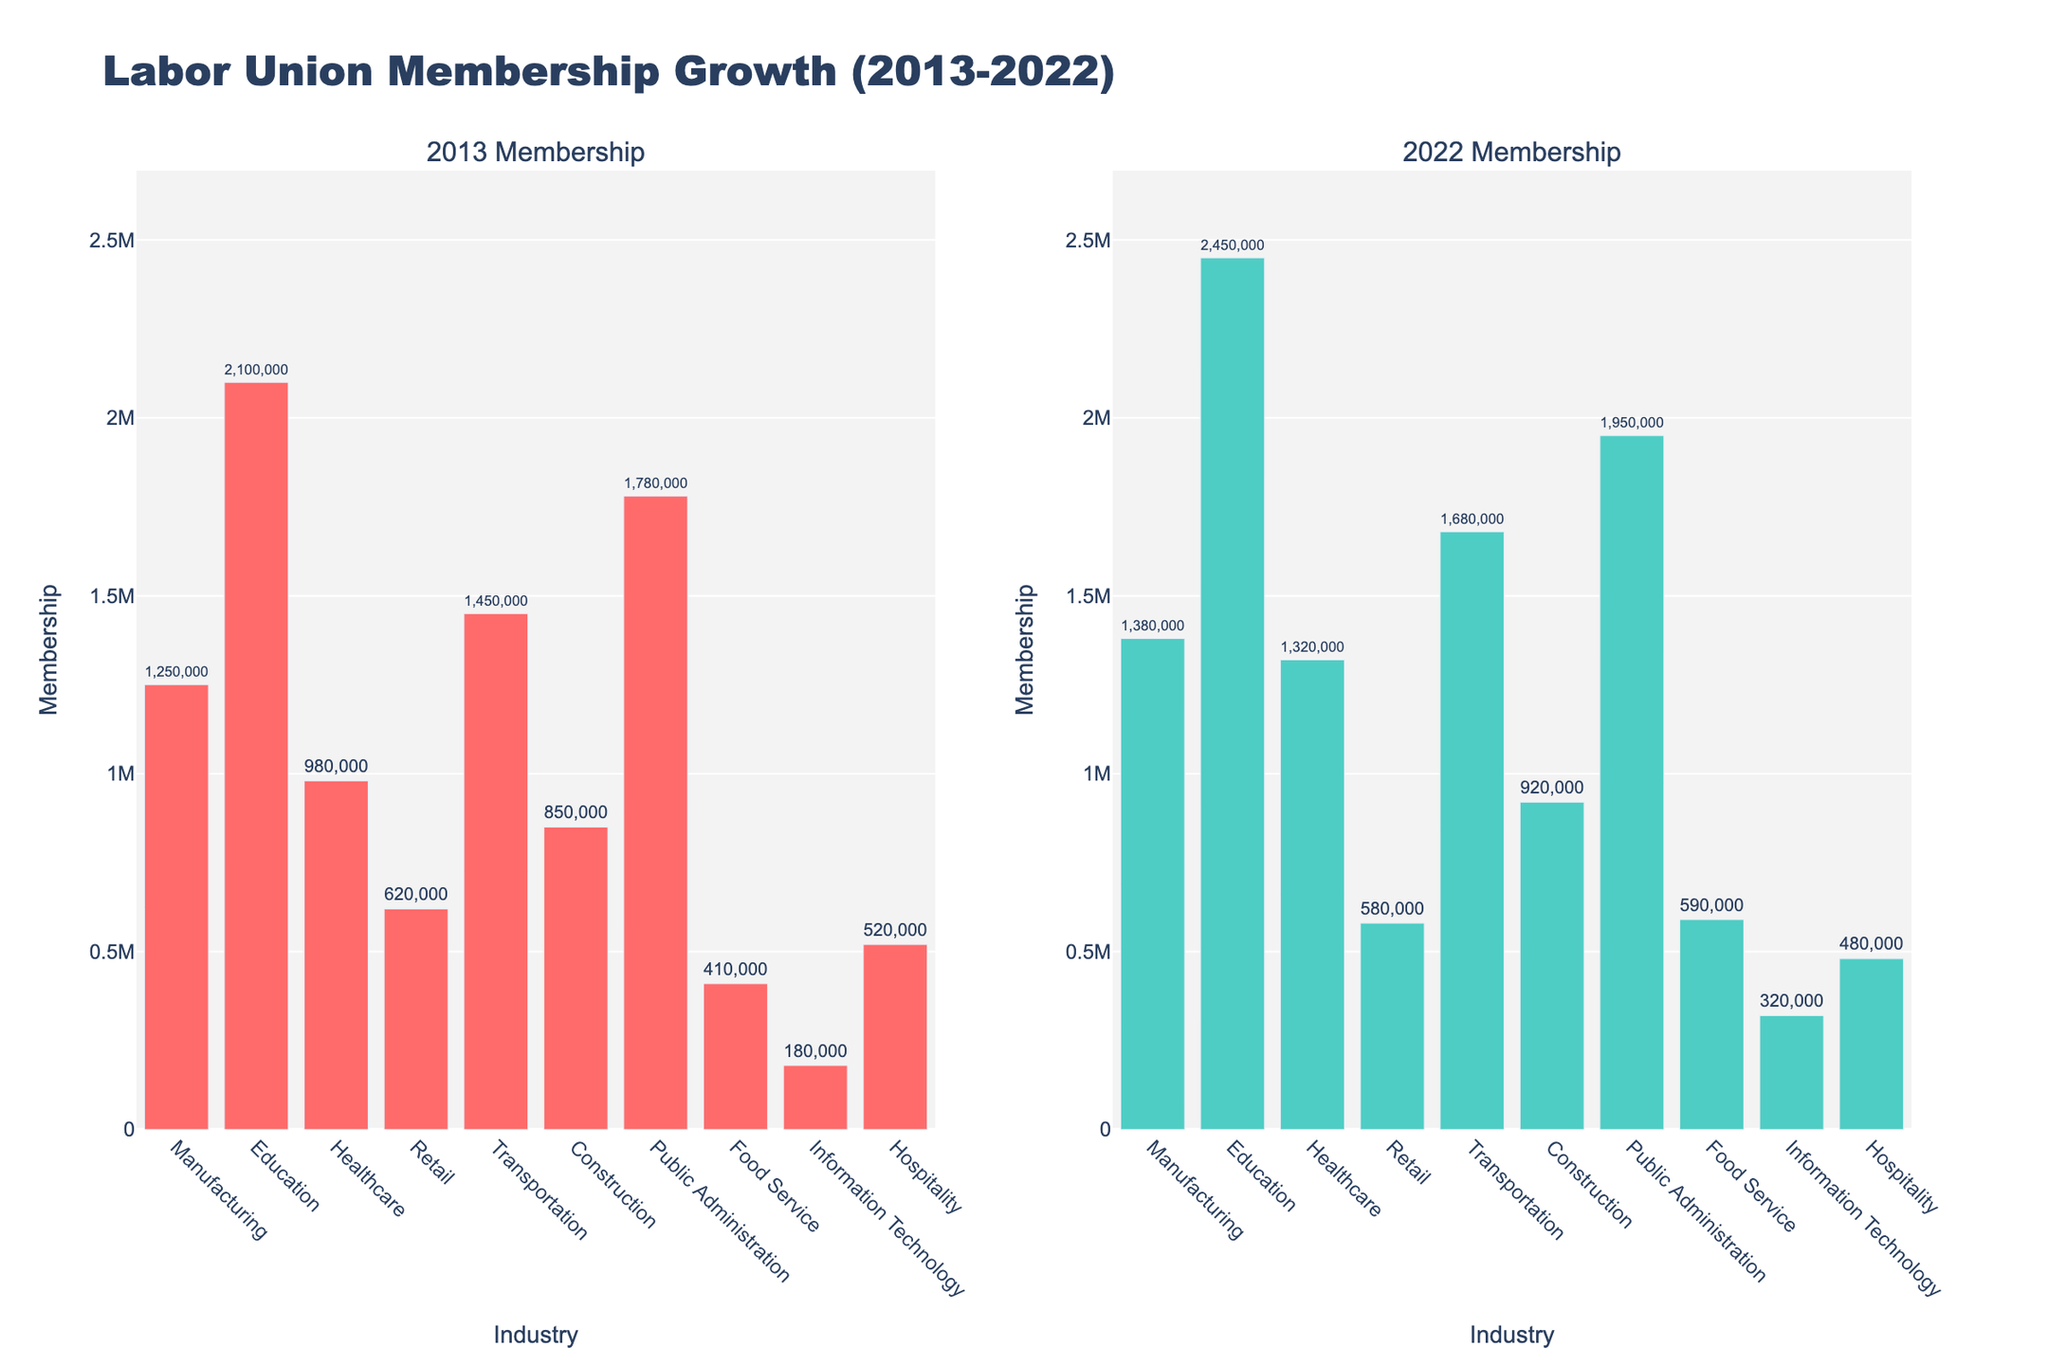What's the industry with the highest membership in 2022? To identify the industry with the highest membership in 2022, look at the heights of the bars in the 2022 subplot. The industry with the tallest bar represents the highest membership.
Answer: Education Which industry saw a decrease in membership from 2013 to 2022? Compare the heights of the bars between 2013 and 2022 for each industry. The industry where the 2022 bar is shorter than the 2013 bar indicates a decrease in membership.
Answer: Retail How much did the membership increase in Healthcare from 2013 to 2022? Find the membership in Healthcare for both years and calculate the difference: 2022 membership - 2013 membership. For Healthcare, it's 1,320,000 - 980,000.
Answer: 340,000 Which industries have less than 1,000,000 members in both 2013 and 2022? Identify industries where the bars are below the 1,000,000 mark on both the 2013 and 2022 subplots.
Answer: Food Service and Information Technology Compare the membership growth between Manufacturing and Transportation. Which grew more in absolute numbers? Subtract the 2013 membership from the 2022 membership for both Manufacturing and Transportation, then compare the results: (1,380,000 - 1,250,000) for Manufacturing and (1,680,000 - 1,450,000) for Transportation.
Answer: Transportation In which industry did membership grow proportionally the most from 2013 to 2022? To find the industry with the highest proportional growth, calculate the growth rate for each industry: (2022 Membership - 2013 Membership) / 2013 Membership, and compare the ratios.
Answer: Information Technology Is the membership growth in Food Service greater than in Hospitality from 2013 to 2022? Compare the increases in membership for Food Service and Hospitality: (590,000 - 410,000) for Food Service and (480,000 - 520,000) for Hospitality. Since Hospitality decreased while Food Service increased, the growth in Food Service is indeed greater.
Answer: Yes On average, did the membership in Construction grow at a faster rate than Healthcare? Calculate the average annual growth rates: (2022 Membership - 2013 Membership) / number of years for both Construction (920,000 - 850,000) / 9 and Healthcare (1,320,000 - 980,000) / 9, and compare the results.
Answer: No What's the total membership across all industries in 2022? Sum the membership numbers for all industries in 2022: 1,380,000 + 2,450,000 + 1,320,000 + 580,000 + 1,680,000 + 920,000 + 1,950,000 + 590,000 + 320,000 + 480,000.
Answer: 11,670,000 